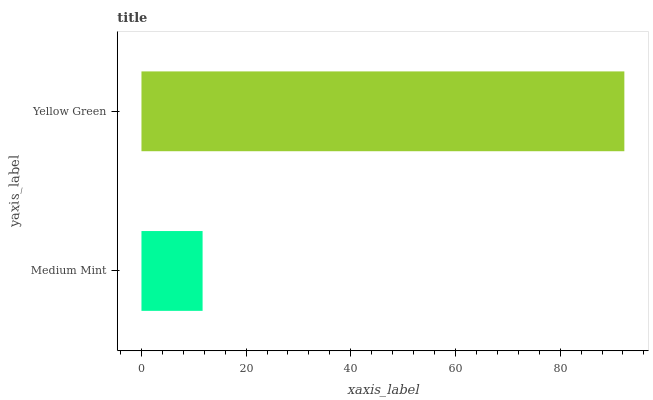Is Medium Mint the minimum?
Answer yes or no. Yes. Is Yellow Green the maximum?
Answer yes or no. Yes. Is Yellow Green the minimum?
Answer yes or no. No. Is Yellow Green greater than Medium Mint?
Answer yes or no. Yes. Is Medium Mint less than Yellow Green?
Answer yes or no. Yes. Is Medium Mint greater than Yellow Green?
Answer yes or no. No. Is Yellow Green less than Medium Mint?
Answer yes or no. No. Is Yellow Green the high median?
Answer yes or no. Yes. Is Medium Mint the low median?
Answer yes or no. Yes. Is Medium Mint the high median?
Answer yes or no. No. Is Yellow Green the low median?
Answer yes or no. No. 